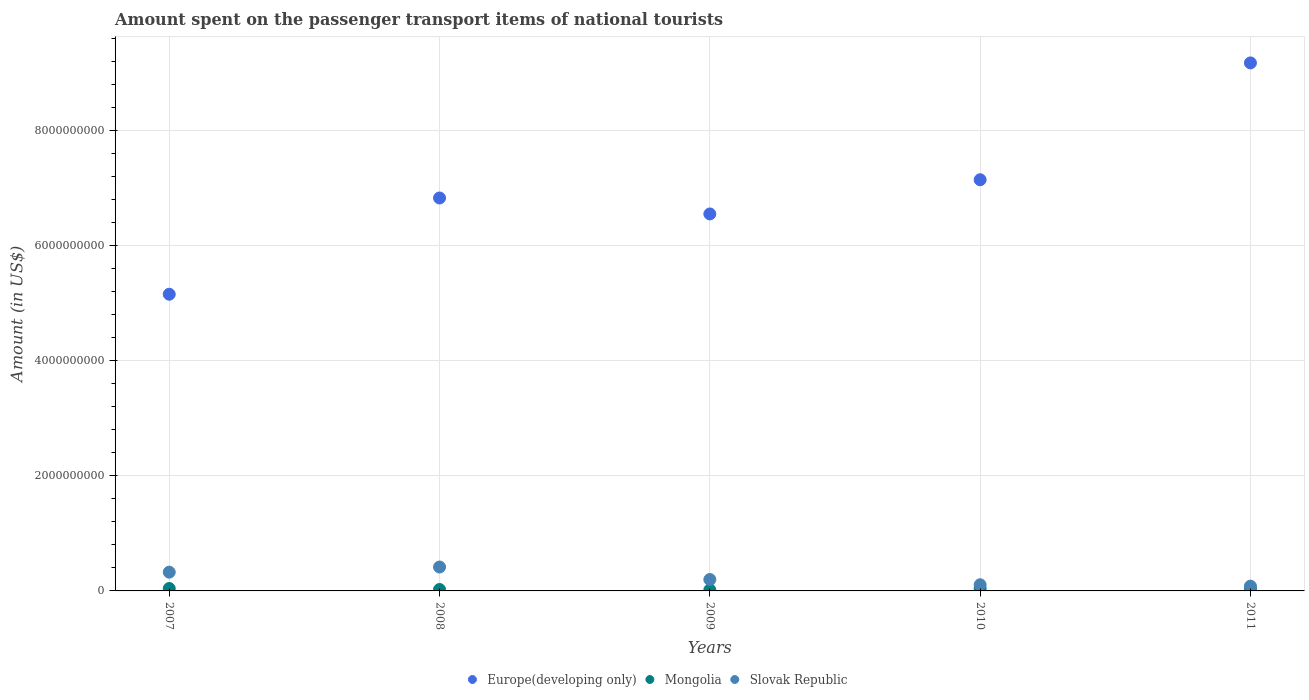What is the amount spent on the passenger transport items of national tourists in Mongolia in 2008?
Provide a short and direct response. 2.50e+07. Across all years, what is the maximum amount spent on the passenger transport items of national tourists in Mongolia?
Ensure brevity in your answer.  4.40e+07. Across all years, what is the minimum amount spent on the passenger transport items of national tourists in Mongolia?
Make the answer very short. 1.80e+07. In which year was the amount spent on the passenger transport items of national tourists in Europe(developing only) minimum?
Provide a short and direct response. 2007. What is the total amount spent on the passenger transport items of national tourists in Slovak Republic in the graph?
Provide a succinct answer. 1.13e+09. What is the difference between the amount spent on the passenger transport items of national tourists in Europe(developing only) in 2008 and that in 2010?
Your response must be concise. -3.17e+08. What is the difference between the amount spent on the passenger transport items of national tourists in Slovak Republic in 2010 and the amount spent on the passenger transport items of national tourists in Mongolia in 2009?
Your answer should be very brief. 8.90e+07. What is the average amount spent on the passenger transport items of national tourists in Europe(developing only) per year?
Your answer should be very brief. 6.97e+09. In the year 2007, what is the difference between the amount spent on the passenger transport items of national tourists in Mongolia and amount spent on the passenger transport items of national tourists in Europe(developing only)?
Offer a very short reply. -5.11e+09. In how many years, is the amount spent on the passenger transport items of national tourists in Mongolia greater than 6800000000 US$?
Make the answer very short. 0. What is the ratio of the amount spent on the passenger transport items of national tourists in Mongolia in 2007 to that in 2010?
Offer a terse response. 0.95. Is the amount spent on the passenger transport items of national tourists in Europe(developing only) in 2007 less than that in 2008?
Provide a succinct answer. Yes. What is the difference between the highest and the second highest amount spent on the passenger transport items of national tourists in Mongolia?
Offer a very short reply. 2.00e+06. What is the difference between the highest and the lowest amount spent on the passenger transport items of national tourists in Mongolia?
Your answer should be very brief. 2.60e+07. In how many years, is the amount spent on the passenger transport items of national tourists in Mongolia greater than the average amount spent on the passenger transport items of national tourists in Mongolia taken over all years?
Ensure brevity in your answer.  3. Is the sum of the amount spent on the passenger transport items of national tourists in Slovak Republic in 2007 and 2009 greater than the maximum amount spent on the passenger transport items of national tourists in Mongolia across all years?
Give a very brief answer. Yes. Is the amount spent on the passenger transport items of national tourists in Slovak Republic strictly less than the amount spent on the passenger transport items of national tourists in Europe(developing only) over the years?
Give a very brief answer. Yes. How many dotlines are there?
Your answer should be compact. 3. How many years are there in the graph?
Offer a very short reply. 5. What is the difference between two consecutive major ticks on the Y-axis?
Provide a succinct answer. 2.00e+09. Are the values on the major ticks of Y-axis written in scientific E-notation?
Provide a short and direct response. No. Does the graph contain any zero values?
Provide a short and direct response. No. How many legend labels are there?
Offer a very short reply. 3. What is the title of the graph?
Ensure brevity in your answer.  Amount spent on the passenger transport items of national tourists. What is the label or title of the Y-axis?
Provide a succinct answer. Amount (in US$). What is the Amount (in US$) in Europe(developing only) in 2007?
Provide a short and direct response. 5.15e+09. What is the Amount (in US$) in Mongolia in 2007?
Offer a very short reply. 4.20e+07. What is the Amount (in US$) in Slovak Republic in 2007?
Your response must be concise. 3.26e+08. What is the Amount (in US$) in Europe(developing only) in 2008?
Your answer should be compact. 6.82e+09. What is the Amount (in US$) in Mongolia in 2008?
Provide a short and direct response. 2.50e+07. What is the Amount (in US$) in Slovak Republic in 2008?
Ensure brevity in your answer.  4.15e+08. What is the Amount (in US$) of Europe(developing only) in 2009?
Your answer should be compact. 6.55e+09. What is the Amount (in US$) in Mongolia in 2009?
Ensure brevity in your answer.  1.80e+07. What is the Amount (in US$) of Slovak Republic in 2009?
Your response must be concise. 1.98e+08. What is the Amount (in US$) in Europe(developing only) in 2010?
Make the answer very short. 7.14e+09. What is the Amount (in US$) of Mongolia in 2010?
Provide a succinct answer. 4.40e+07. What is the Amount (in US$) of Slovak Republic in 2010?
Make the answer very short. 1.07e+08. What is the Amount (in US$) in Europe(developing only) in 2011?
Your response must be concise. 9.17e+09. What is the Amount (in US$) of Mongolia in 2011?
Provide a succinct answer. 4.00e+07. What is the Amount (in US$) in Slovak Republic in 2011?
Keep it short and to the point. 8.30e+07. Across all years, what is the maximum Amount (in US$) in Europe(developing only)?
Your answer should be compact. 9.17e+09. Across all years, what is the maximum Amount (in US$) of Mongolia?
Provide a succinct answer. 4.40e+07. Across all years, what is the maximum Amount (in US$) in Slovak Republic?
Provide a succinct answer. 4.15e+08. Across all years, what is the minimum Amount (in US$) in Europe(developing only)?
Your response must be concise. 5.15e+09. Across all years, what is the minimum Amount (in US$) of Mongolia?
Make the answer very short. 1.80e+07. Across all years, what is the minimum Amount (in US$) in Slovak Republic?
Provide a short and direct response. 8.30e+07. What is the total Amount (in US$) in Europe(developing only) in the graph?
Offer a very short reply. 3.48e+1. What is the total Amount (in US$) of Mongolia in the graph?
Your response must be concise. 1.69e+08. What is the total Amount (in US$) in Slovak Republic in the graph?
Ensure brevity in your answer.  1.13e+09. What is the difference between the Amount (in US$) in Europe(developing only) in 2007 and that in 2008?
Provide a short and direct response. -1.67e+09. What is the difference between the Amount (in US$) of Mongolia in 2007 and that in 2008?
Your answer should be compact. 1.70e+07. What is the difference between the Amount (in US$) of Slovak Republic in 2007 and that in 2008?
Ensure brevity in your answer.  -8.90e+07. What is the difference between the Amount (in US$) of Europe(developing only) in 2007 and that in 2009?
Give a very brief answer. -1.39e+09. What is the difference between the Amount (in US$) in Mongolia in 2007 and that in 2009?
Your answer should be very brief. 2.40e+07. What is the difference between the Amount (in US$) in Slovak Republic in 2007 and that in 2009?
Your response must be concise. 1.28e+08. What is the difference between the Amount (in US$) in Europe(developing only) in 2007 and that in 2010?
Offer a very short reply. -1.99e+09. What is the difference between the Amount (in US$) in Slovak Republic in 2007 and that in 2010?
Offer a terse response. 2.19e+08. What is the difference between the Amount (in US$) in Europe(developing only) in 2007 and that in 2011?
Make the answer very short. -4.02e+09. What is the difference between the Amount (in US$) in Slovak Republic in 2007 and that in 2011?
Offer a very short reply. 2.43e+08. What is the difference between the Amount (in US$) in Europe(developing only) in 2008 and that in 2009?
Your answer should be compact. 2.77e+08. What is the difference between the Amount (in US$) of Slovak Republic in 2008 and that in 2009?
Offer a terse response. 2.17e+08. What is the difference between the Amount (in US$) of Europe(developing only) in 2008 and that in 2010?
Offer a very short reply. -3.17e+08. What is the difference between the Amount (in US$) in Mongolia in 2008 and that in 2010?
Offer a very short reply. -1.90e+07. What is the difference between the Amount (in US$) in Slovak Republic in 2008 and that in 2010?
Give a very brief answer. 3.08e+08. What is the difference between the Amount (in US$) of Europe(developing only) in 2008 and that in 2011?
Offer a very short reply. -2.35e+09. What is the difference between the Amount (in US$) of Mongolia in 2008 and that in 2011?
Offer a terse response. -1.50e+07. What is the difference between the Amount (in US$) in Slovak Republic in 2008 and that in 2011?
Offer a terse response. 3.32e+08. What is the difference between the Amount (in US$) in Europe(developing only) in 2009 and that in 2010?
Your answer should be very brief. -5.94e+08. What is the difference between the Amount (in US$) in Mongolia in 2009 and that in 2010?
Offer a terse response. -2.60e+07. What is the difference between the Amount (in US$) in Slovak Republic in 2009 and that in 2010?
Give a very brief answer. 9.10e+07. What is the difference between the Amount (in US$) of Europe(developing only) in 2009 and that in 2011?
Offer a terse response. -2.62e+09. What is the difference between the Amount (in US$) in Mongolia in 2009 and that in 2011?
Provide a succinct answer. -2.20e+07. What is the difference between the Amount (in US$) in Slovak Republic in 2009 and that in 2011?
Provide a succinct answer. 1.15e+08. What is the difference between the Amount (in US$) of Europe(developing only) in 2010 and that in 2011?
Offer a terse response. -2.03e+09. What is the difference between the Amount (in US$) in Slovak Republic in 2010 and that in 2011?
Provide a short and direct response. 2.40e+07. What is the difference between the Amount (in US$) in Europe(developing only) in 2007 and the Amount (in US$) in Mongolia in 2008?
Your response must be concise. 5.13e+09. What is the difference between the Amount (in US$) in Europe(developing only) in 2007 and the Amount (in US$) in Slovak Republic in 2008?
Ensure brevity in your answer.  4.74e+09. What is the difference between the Amount (in US$) in Mongolia in 2007 and the Amount (in US$) in Slovak Republic in 2008?
Offer a very short reply. -3.73e+08. What is the difference between the Amount (in US$) in Europe(developing only) in 2007 and the Amount (in US$) in Mongolia in 2009?
Your answer should be very brief. 5.13e+09. What is the difference between the Amount (in US$) of Europe(developing only) in 2007 and the Amount (in US$) of Slovak Republic in 2009?
Your answer should be very brief. 4.95e+09. What is the difference between the Amount (in US$) in Mongolia in 2007 and the Amount (in US$) in Slovak Republic in 2009?
Make the answer very short. -1.56e+08. What is the difference between the Amount (in US$) in Europe(developing only) in 2007 and the Amount (in US$) in Mongolia in 2010?
Give a very brief answer. 5.11e+09. What is the difference between the Amount (in US$) in Europe(developing only) in 2007 and the Amount (in US$) in Slovak Republic in 2010?
Provide a succinct answer. 5.05e+09. What is the difference between the Amount (in US$) of Mongolia in 2007 and the Amount (in US$) of Slovak Republic in 2010?
Offer a terse response. -6.50e+07. What is the difference between the Amount (in US$) of Europe(developing only) in 2007 and the Amount (in US$) of Mongolia in 2011?
Provide a short and direct response. 5.11e+09. What is the difference between the Amount (in US$) of Europe(developing only) in 2007 and the Amount (in US$) of Slovak Republic in 2011?
Give a very brief answer. 5.07e+09. What is the difference between the Amount (in US$) of Mongolia in 2007 and the Amount (in US$) of Slovak Republic in 2011?
Ensure brevity in your answer.  -4.10e+07. What is the difference between the Amount (in US$) in Europe(developing only) in 2008 and the Amount (in US$) in Mongolia in 2009?
Your answer should be very brief. 6.81e+09. What is the difference between the Amount (in US$) of Europe(developing only) in 2008 and the Amount (in US$) of Slovak Republic in 2009?
Provide a succinct answer. 6.63e+09. What is the difference between the Amount (in US$) of Mongolia in 2008 and the Amount (in US$) of Slovak Republic in 2009?
Your response must be concise. -1.73e+08. What is the difference between the Amount (in US$) in Europe(developing only) in 2008 and the Amount (in US$) in Mongolia in 2010?
Keep it short and to the point. 6.78e+09. What is the difference between the Amount (in US$) of Europe(developing only) in 2008 and the Amount (in US$) of Slovak Republic in 2010?
Offer a terse response. 6.72e+09. What is the difference between the Amount (in US$) of Mongolia in 2008 and the Amount (in US$) of Slovak Republic in 2010?
Provide a succinct answer. -8.20e+07. What is the difference between the Amount (in US$) of Europe(developing only) in 2008 and the Amount (in US$) of Mongolia in 2011?
Offer a very short reply. 6.78e+09. What is the difference between the Amount (in US$) of Europe(developing only) in 2008 and the Amount (in US$) of Slovak Republic in 2011?
Your response must be concise. 6.74e+09. What is the difference between the Amount (in US$) of Mongolia in 2008 and the Amount (in US$) of Slovak Republic in 2011?
Provide a succinct answer. -5.80e+07. What is the difference between the Amount (in US$) of Europe(developing only) in 2009 and the Amount (in US$) of Mongolia in 2010?
Provide a succinct answer. 6.50e+09. What is the difference between the Amount (in US$) of Europe(developing only) in 2009 and the Amount (in US$) of Slovak Republic in 2010?
Give a very brief answer. 6.44e+09. What is the difference between the Amount (in US$) of Mongolia in 2009 and the Amount (in US$) of Slovak Republic in 2010?
Your answer should be very brief. -8.90e+07. What is the difference between the Amount (in US$) of Europe(developing only) in 2009 and the Amount (in US$) of Mongolia in 2011?
Provide a short and direct response. 6.51e+09. What is the difference between the Amount (in US$) of Europe(developing only) in 2009 and the Amount (in US$) of Slovak Republic in 2011?
Offer a terse response. 6.46e+09. What is the difference between the Amount (in US$) of Mongolia in 2009 and the Amount (in US$) of Slovak Republic in 2011?
Give a very brief answer. -6.50e+07. What is the difference between the Amount (in US$) of Europe(developing only) in 2010 and the Amount (in US$) of Mongolia in 2011?
Make the answer very short. 7.10e+09. What is the difference between the Amount (in US$) in Europe(developing only) in 2010 and the Amount (in US$) in Slovak Republic in 2011?
Give a very brief answer. 7.06e+09. What is the difference between the Amount (in US$) in Mongolia in 2010 and the Amount (in US$) in Slovak Republic in 2011?
Provide a succinct answer. -3.90e+07. What is the average Amount (in US$) in Europe(developing only) per year?
Keep it short and to the point. 6.97e+09. What is the average Amount (in US$) of Mongolia per year?
Offer a very short reply. 3.38e+07. What is the average Amount (in US$) of Slovak Republic per year?
Offer a very short reply. 2.26e+08. In the year 2007, what is the difference between the Amount (in US$) of Europe(developing only) and Amount (in US$) of Mongolia?
Provide a short and direct response. 5.11e+09. In the year 2007, what is the difference between the Amount (in US$) in Europe(developing only) and Amount (in US$) in Slovak Republic?
Your response must be concise. 4.83e+09. In the year 2007, what is the difference between the Amount (in US$) of Mongolia and Amount (in US$) of Slovak Republic?
Provide a short and direct response. -2.84e+08. In the year 2008, what is the difference between the Amount (in US$) in Europe(developing only) and Amount (in US$) in Mongolia?
Offer a very short reply. 6.80e+09. In the year 2008, what is the difference between the Amount (in US$) of Europe(developing only) and Amount (in US$) of Slovak Republic?
Make the answer very short. 6.41e+09. In the year 2008, what is the difference between the Amount (in US$) in Mongolia and Amount (in US$) in Slovak Republic?
Offer a terse response. -3.90e+08. In the year 2009, what is the difference between the Amount (in US$) in Europe(developing only) and Amount (in US$) in Mongolia?
Ensure brevity in your answer.  6.53e+09. In the year 2009, what is the difference between the Amount (in US$) in Europe(developing only) and Amount (in US$) in Slovak Republic?
Offer a terse response. 6.35e+09. In the year 2009, what is the difference between the Amount (in US$) of Mongolia and Amount (in US$) of Slovak Republic?
Ensure brevity in your answer.  -1.80e+08. In the year 2010, what is the difference between the Amount (in US$) in Europe(developing only) and Amount (in US$) in Mongolia?
Keep it short and to the point. 7.10e+09. In the year 2010, what is the difference between the Amount (in US$) in Europe(developing only) and Amount (in US$) in Slovak Republic?
Provide a short and direct response. 7.03e+09. In the year 2010, what is the difference between the Amount (in US$) in Mongolia and Amount (in US$) in Slovak Republic?
Provide a short and direct response. -6.30e+07. In the year 2011, what is the difference between the Amount (in US$) of Europe(developing only) and Amount (in US$) of Mongolia?
Provide a succinct answer. 9.13e+09. In the year 2011, what is the difference between the Amount (in US$) of Europe(developing only) and Amount (in US$) of Slovak Republic?
Make the answer very short. 9.09e+09. In the year 2011, what is the difference between the Amount (in US$) in Mongolia and Amount (in US$) in Slovak Republic?
Ensure brevity in your answer.  -4.30e+07. What is the ratio of the Amount (in US$) of Europe(developing only) in 2007 to that in 2008?
Ensure brevity in your answer.  0.76. What is the ratio of the Amount (in US$) of Mongolia in 2007 to that in 2008?
Your answer should be compact. 1.68. What is the ratio of the Amount (in US$) in Slovak Republic in 2007 to that in 2008?
Provide a succinct answer. 0.79. What is the ratio of the Amount (in US$) in Europe(developing only) in 2007 to that in 2009?
Provide a short and direct response. 0.79. What is the ratio of the Amount (in US$) in Mongolia in 2007 to that in 2009?
Make the answer very short. 2.33. What is the ratio of the Amount (in US$) in Slovak Republic in 2007 to that in 2009?
Ensure brevity in your answer.  1.65. What is the ratio of the Amount (in US$) in Europe(developing only) in 2007 to that in 2010?
Your answer should be very brief. 0.72. What is the ratio of the Amount (in US$) of Mongolia in 2007 to that in 2010?
Give a very brief answer. 0.95. What is the ratio of the Amount (in US$) in Slovak Republic in 2007 to that in 2010?
Provide a succinct answer. 3.05. What is the ratio of the Amount (in US$) of Europe(developing only) in 2007 to that in 2011?
Provide a succinct answer. 0.56. What is the ratio of the Amount (in US$) of Slovak Republic in 2007 to that in 2011?
Your answer should be very brief. 3.93. What is the ratio of the Amount (in US$) in Europe(developing only) in 2008 to that in 2009?
Your answer should be compact. 1.04. What is the ratio of the Amount (in US$) of Mongolia in 2008 to that in 2009?
Provide a short and direct response. 1.39. What is the ratio of the Amount (in US$) of Slovak Republic in 2008 to that in 2009?
Your answer should be compact. 2.1. What is the ratio of the Amount (in US$) in Europe(developing only) in 2008 to that in 2010?
Offer a very short reply. 0.96. What is the ratio of the Amount (in US$) of Mongolia in 2008 to that in 2010?
Give a very brief answer. 0.57. What is the ratio of the Amount (in US$) of Slovak Republic in 2008 to that in 2010?
Your answer should be compact. 3.88. What is the ratio of the Amount (in US$) of Europe(developing only) in 2008 to that in 2011?
Your response must be concise. 0.74. What is the ratio of the Amount (in US$) in Slovak Republic in 2008 to that in 2011?
Provide a succinct answer. 5. What is the ratio of the Amount (in US$) in Europe(developing only) in 2009 to that in 2010?
Provide a short and direct response. 0.92. What is the ratio of the Amount (in US$) of Mongolia in 2009 to that in 2010?
Give a very brief answer. 0.41. What is the ratio of the Amount (in US$) in Slovak Republic in 2009 to that in 2010?
Make the answer very short. 1.85. What is the ratio of the Amount (in US$) in Europe(developing only) in 2009 to that in 2011?
Provide a short and direct response. 0.71. What is the ratio of the Amount (in US$) of Mongolia in 2009 to that in 2011?
Offer a terse response. 0.45. What is the ratio of the Amount (in US$) in Slovak Republic in 2009 to that in 2011?
Provide a succinct answer. 2.39. What is the ratio of the Amount (in US$) in Europe(developing only) in 2010 to that in 2011?
Your answer should be compact. 0.78. What is the ratio of the Amount (in US$) of Slovak Republic in 2010 to that in 2011?
Your answer should be compact. 1.29. What is the difference between the highest and the second highest Amount (in US$) of Europe(developing only)?
Make the answer very short. 2.03e+09. What is the difference between the highest and the second highest Amount (in US$) of Slovak Republic?
Offer a terse response. 8.90e+07. What is the difference between the highest and the lowest Amount (in US$) in Europe(developing only)?
Provide a succinct answer. 4.02e+09. What is the difference between the highest and the lowest Amount (in US$) of Mongolia?
Give a very brief answer. 2.60e+07. What is the difference between the highest and the lowest Amount (in US$) of Slovak Republic?
Provide a short and direct response. 3.32e+08. 